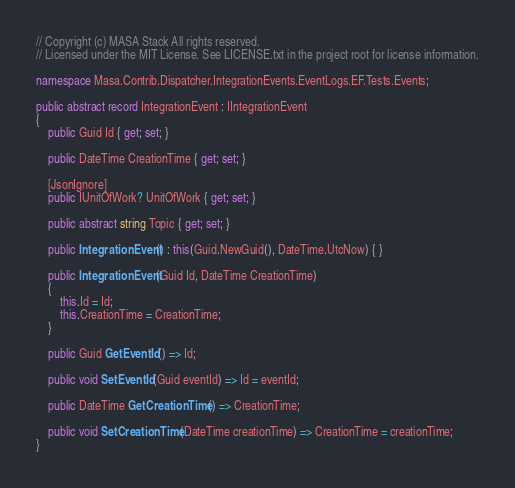<code> <loc_0><loc_0><loc_500><loc_500><_C#_>// Copyright (c) MASA Stack All rights reserved.
// Licensed under the MIT License. See LICENSE.txt in the project root for license information.

namespace Masa.Contrib.Dispatcher.IntegrationEvents.EventLogs.EF.Tests.Events;

public abstract record IntegrationEvent : IIntegrationEvent
{
    public Guid Id { get; set; }

    public DateTime CreationTime { get; set; }

    [JsonIgnore]
    public IUnitOfWork? UnitOfWork { get; set; }

    public abstract string Topic { get; set; }

    public IntegrationEvent() : this(Guid.NewGuid(), DateTime.UtcNow) { }

    public IntegrationEvent(Guid Id, DateTime CreationTime)
    {
        this.Id = Id;
        this.CreationTime = CreationTime;
    }

    public Guid GetEventId() => Id;

    public void SetEventId(Guid eventId) => Id = eventId;

    public DateTime GetCreationTime() => CreationTime;

    public void SetCreationTime(DateTime creationTime) => CreationTime = creationTime;
}
</code> 